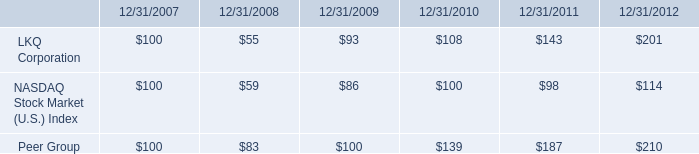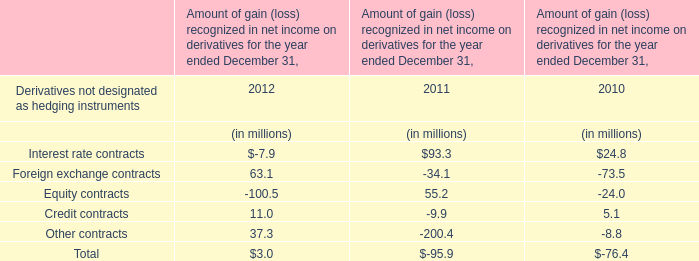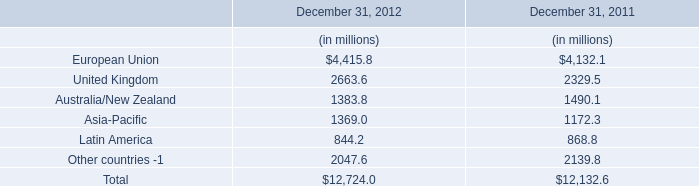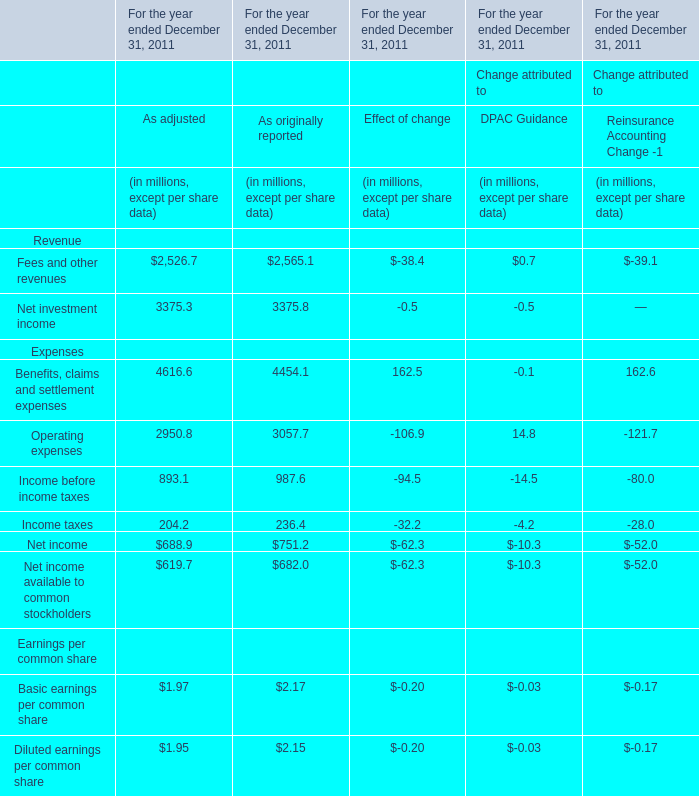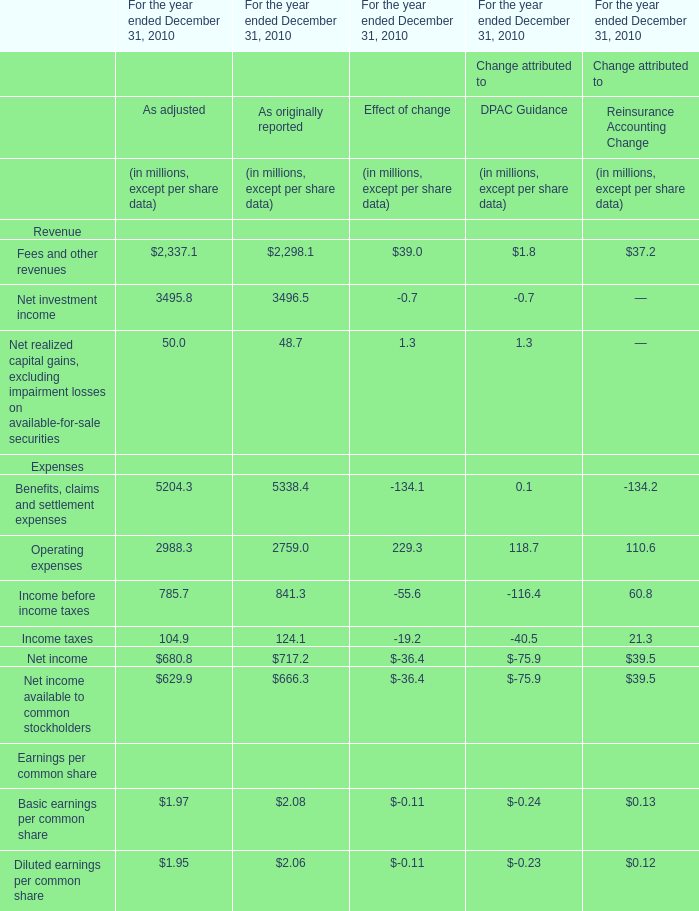What is the sum of As originally reported in 2011 for Revenue ? (in million) 
Computations: (2565.1 + 3375.8)
Answer: 5940.9. 